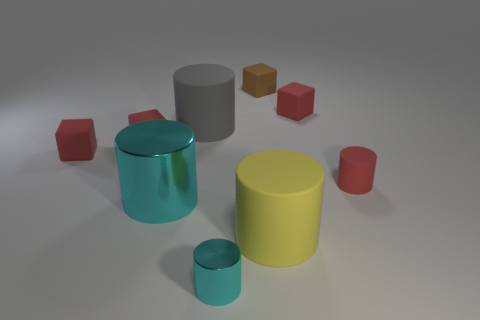There is a cyan metallic cylinder behind the tiny cyan shiny thing; how many metal cylinders are right of it?
Your response must be concise. 1. What size is the brown thing that is made of the same material as the big gray object?
Your answer should be compact. Small. How big is the red rubber cylinder?
Give a very brief answer. Small. Is the material of the tiny brown cube the same as the big gray thing?
Offer a terse response. Yes. What number of balls are small things or red things?
Your answer should be compact. 0. There is a cube that is on the right side of the large matte object right of the small brown block; what is its color?
Provide a short and direct response. Red. There is another cylinder that is the same color as the big metal cylinder; what is its size?
Provide a short and direct response. Small. There is a tiny cylinder behind the tiny shiny object that is in front of the brown object; what number of cyan cylinders are on the left side of it?
Your answer should be very brief. 2. Do the shiny thing in front of the large cyan thing and the cyan metal object behind the tiny metal cylinder have the same shape?
Your response must be concise. Yes. How many objects are yellow objects or large red rubber blocks?
Make the answer very short. 1. 